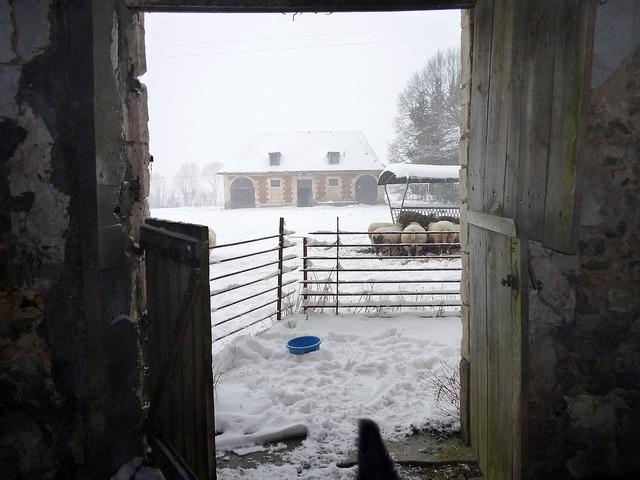How many black sheep are there in the picture?
Keep it brief. 0. What is covering the ground?
Keep it brief. Snow. Is it cold outside?
Keep it brief. Yes. What is the blue object?
Write a very short answer. Bowl. Will the horse be able to leave the stall without help?
Give a very brief answer. No. What species of giraffe is in the photo?
Keep it brief. None. 